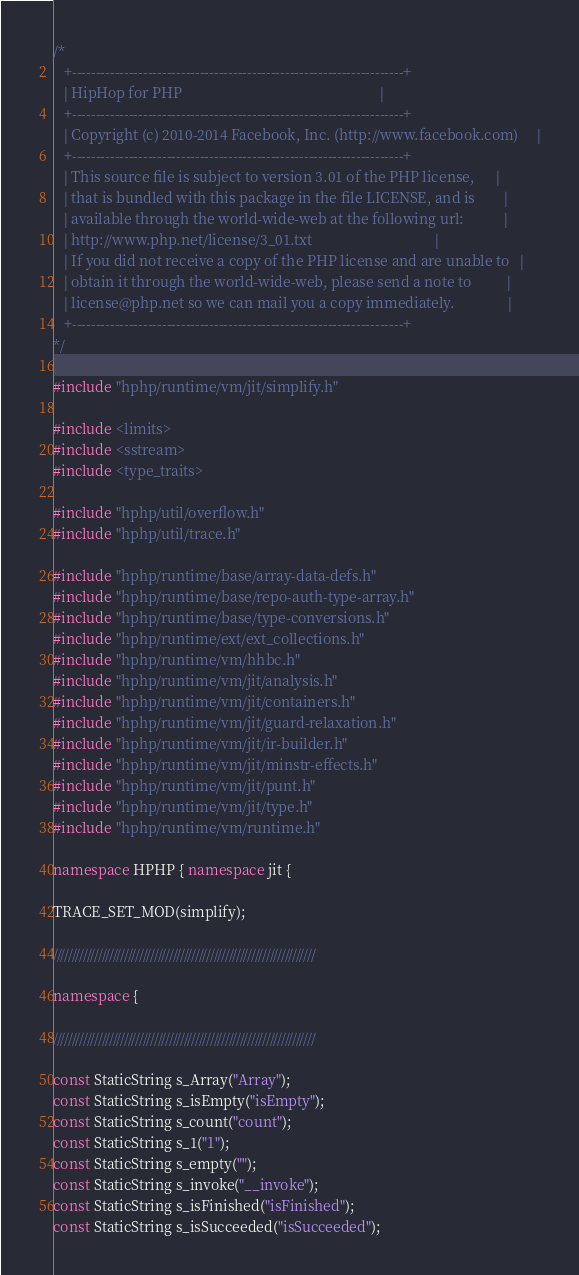Convert code to text. <code><loc_0><loc_0><loc_500><loc_500><_C++_>/*
   +----------------------------------------------------------------------+
   | HipHop for PHP                                                       |
   +----------------------------------------------------------------------+
   | Copyright (c) 2010-2014 Facebook, Inc. (http://www.facebook.com)     |
   +----------------------------------------------------------------------+
   | This source file is subject to version 3.01 of the PHP license,      |
   | that is bundled with this package in the file LICENSE, and is        |
   | available through the world-wide-web at the following url:           |
   | http://www.php.net/license/3_01.txt                                  |
   | If you did not receive a copy of the PHP license and are unable to   |
   | obtain it through the world-wide-web, please send a note to          |
   | license@php.net so we can mail you a copy immediately.               |
   +----------------------------------------------------------------------+
*/

#include "hphp/runtime/vm/jit/simplify.h"

#include <limits>
#include <sstream>
#include <type_traits>

#include "hphp/util/overflow.h"
#include "hphp/util/trace.h"

#include "hphp/runtime/base/array-data-defs.h"
#include "hphp/runtime/base/repo-auth-type-array.h"
#include "hphp/runtime/base/type-conversions.h"
#include "hphp/runtime/ext/ext_collections.h"
#include "hphp/runtime/vm/hhbc.h"
#include "hphp/runtime/vm/jit/analysis.h"
#include "hphp/runtime/vm/jit/containers.h"
#include "hphp/runtime/vm/jit/guard-relaxation.h"
#include "hphp/runtime/vm/jit/ir-builder.h"
#include "hphp/runtime/vm/jit/minstr-effects.h"
#include "hphp/runtime/vm/jit/punt.h"
#include "hphp/runtime/vm/jit/type.h"
#include "hphp/runtime/vm/runtime.h"

namespace HPHP { namespace jit {

TRACE_SET_MOD(simplify);

//////////////////////////////////////////////////////////////////////

namespace {

//////////////////////////////////////////////////////////////////////

const StaticString s_Array("Array");
const StaticString s_isEmpty("isEmpty");
const StaticString s_count("count");
const StaticString s_1("1");
const StaticString s_empty("");
const StaticString s_invoke("__invoke");
const StaticString s_isFinished("isFinished");
const StaticString s_isSucceeded("isSucceeded");</code> 